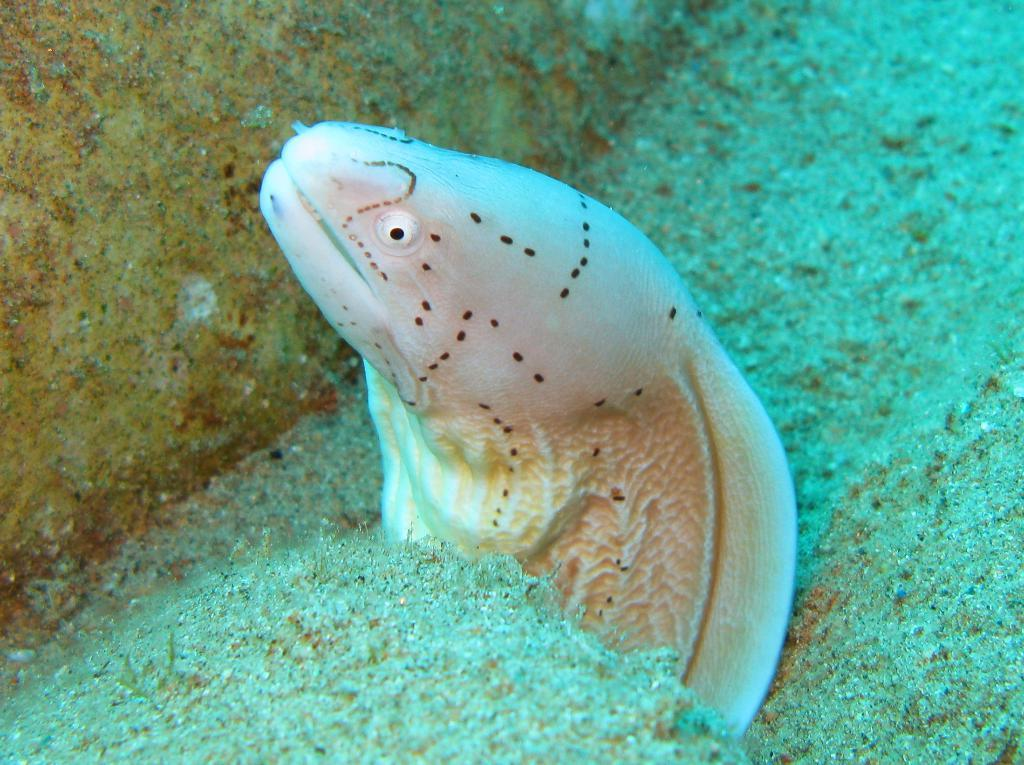Where was the image taken? The image is taken inside the water. What can be seen swimming in the water? There is a fish in the image. What type of terrain is visible in the foreground of the image? There is sand visible in the foreground of the image. What object can be seen in the top left area of the image? There is a stone-like object in the top left area of the image. What is the name of the person who answered the question about the stone-like object? There is no person answering questions in the image, as it is a photograph. 